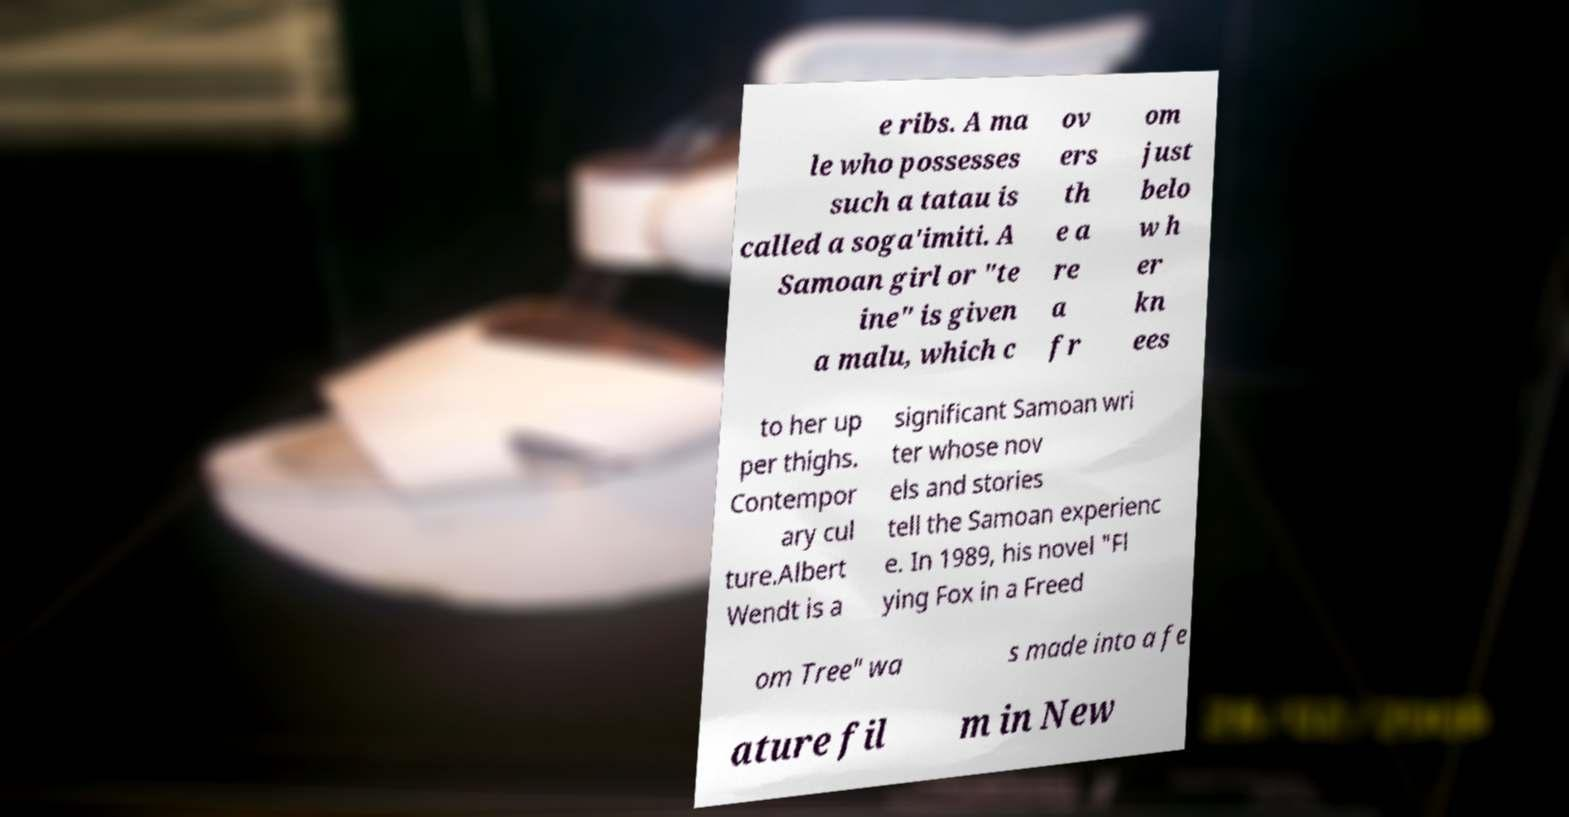Could you assist in decoding the text presented in this image and type it out clearly? e ribs. A ma le who possesses such a tatau is called a soga'imiti. A Samoan girl or "te ine" is given a malu, which c ov ers th e a re a fr om just belo w h er kn ees to her up per thighs. Contempor ary cul ture.Albert Wendt is a significant Samoan wri ter whose nov els and stories tell the Samoan experienc e. In 1989, his novel "Fl ying Fox in a Freed om Tree" wa s made into a fe ature fil m in New 